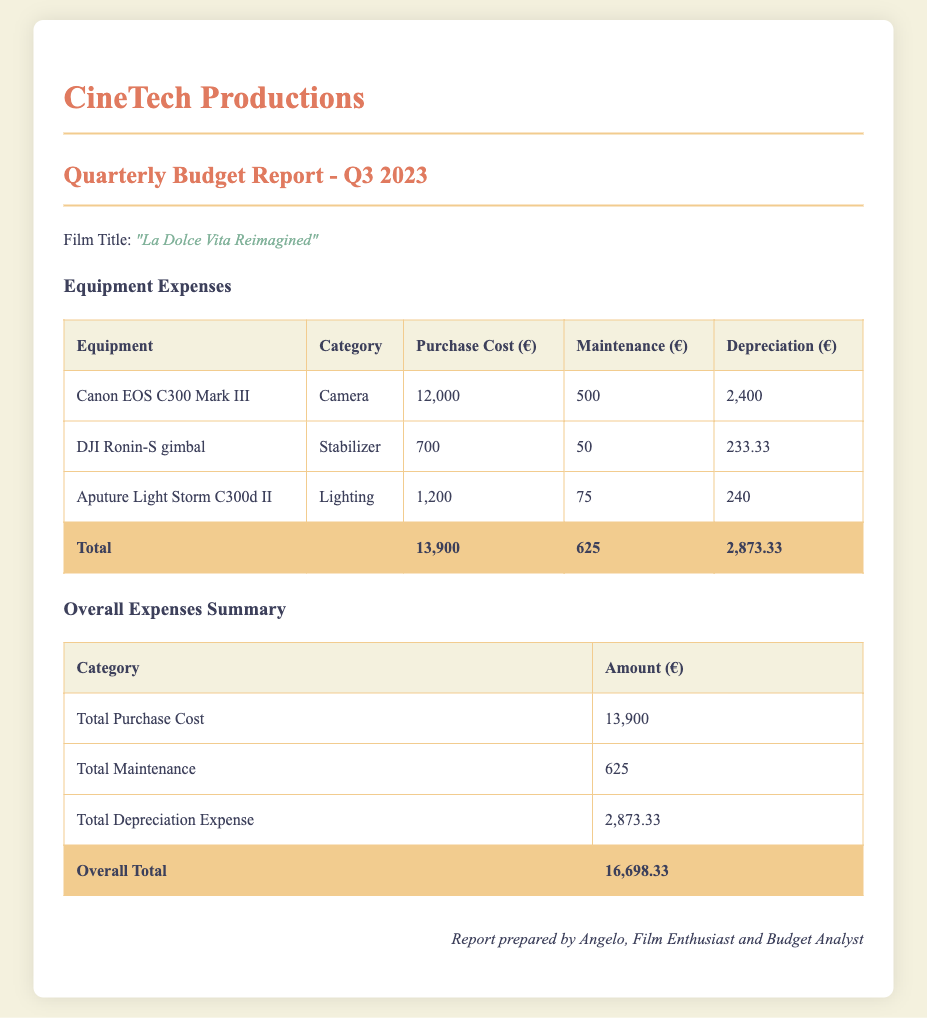What is the film title? The film title is specified in the document and is listed under the section "Film Title."
Answer: "La Dolce Vita Reimagined" What is the purchase cost for the Canon EOS C300 Mark III? This cost is provided in the table under the "Purchase Cost" column for the respective equipment.
Answer: 12,000 What is the total maintenance expense? This is the summed maintenance for all equipment listed in the "Overall Expenses Summary" section of the report.
Answer: 625 What is the depreciation amount for the DJI Ronin-S gimbal? The depreciation for each piece of equipment is noted in the table and refers to the specific line for the gimbal.
Answer: 233.33 What is the overall total expenditure? The overall total is shown at the bottom of the "Overall Expenses Summary" table and is the sum of all individual expenses.
Answer: 16,698.33 How much is the total depreciation expense? The total depreciation is specifically mentioned in the "Overall Expenses Summary" table.
Answer: 2,873.33 What equipment falls under the category of Lighting? The "Category" column specifies the type of each piece of equipment, and the Lighting category includes the one listed.
Answer: Aputure Light Storm C300d II What is the maintenance cost for the Aputure Light Storm C300d II? This cost is indicated in the maintenance column of the equipment table.
Answer: 75 What is the subtotal for purchase costs? The subtotal is provided in the "Overall Expenses Summary" section and reflects the total of all purchase costs calculated.
Answer: 13,900 